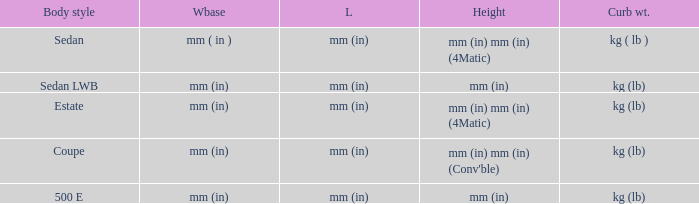What's the curb weight of the model with a wheelbase of mm (in) and height of mm (in) mm (in) (4Matic)? Kg ( lb ), kg (lb). 